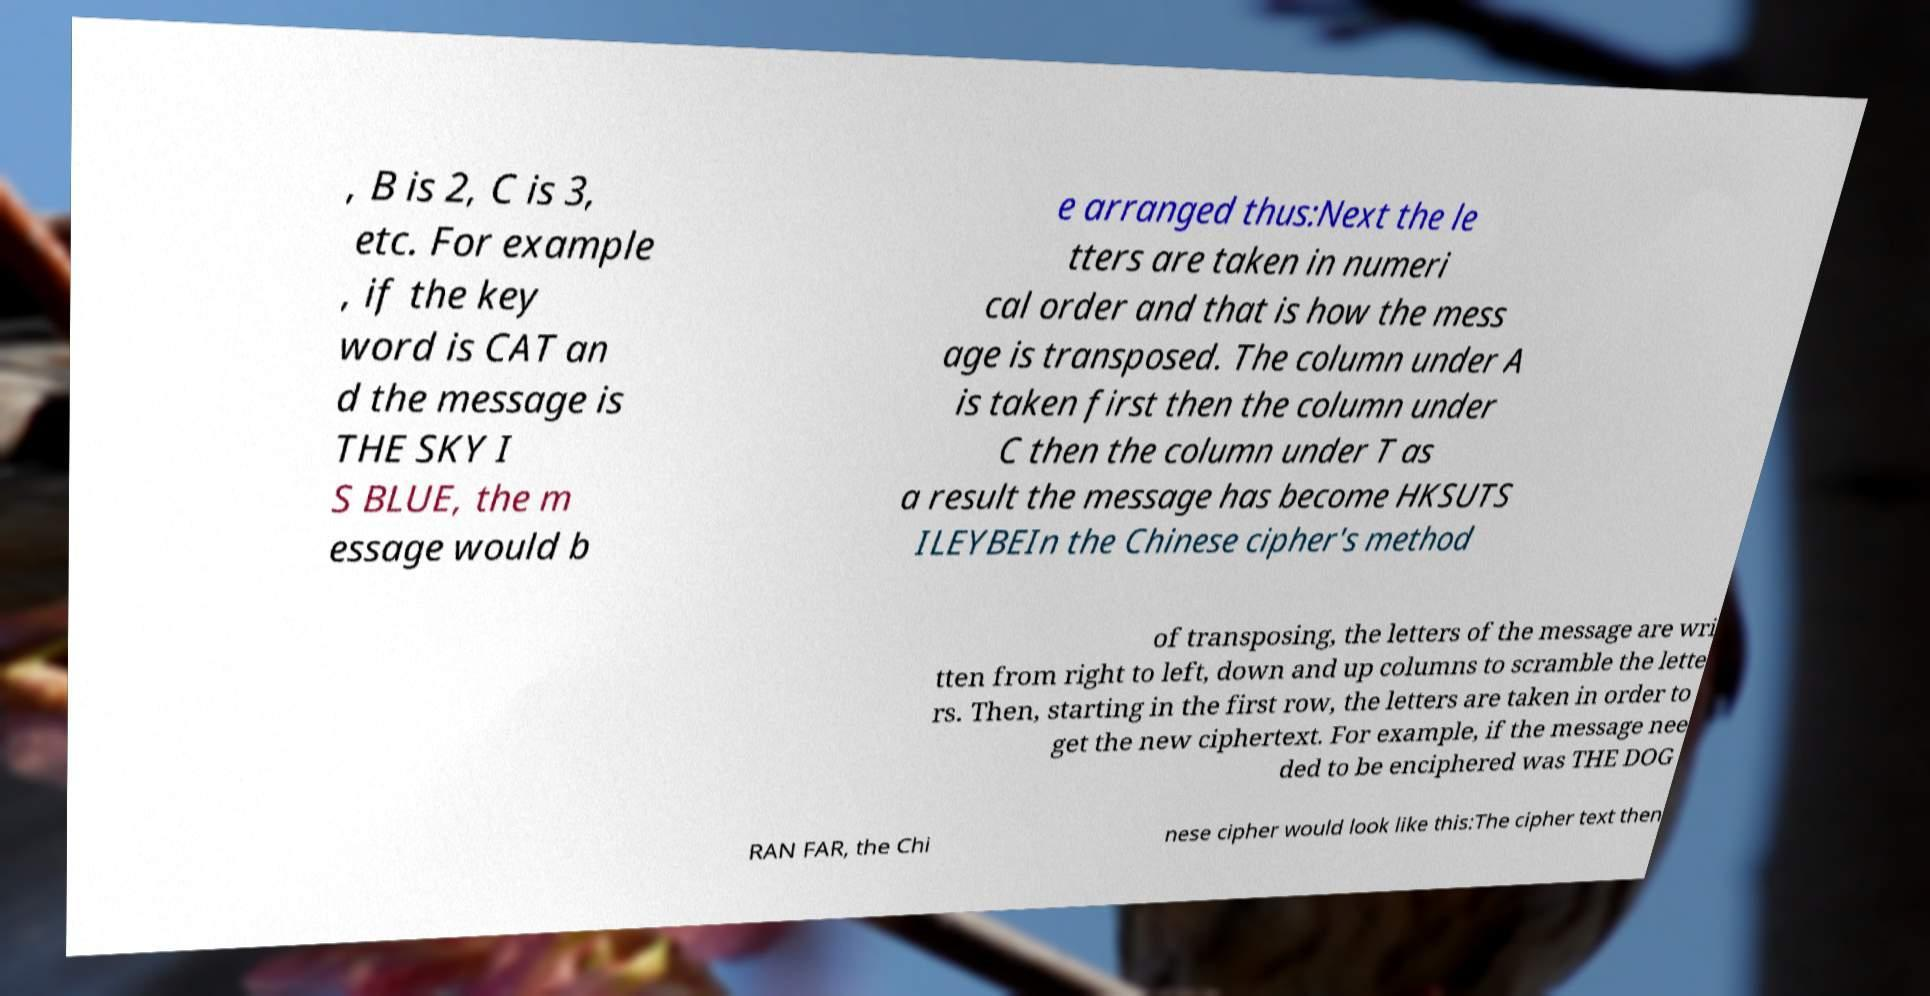I need the written content from this picture converted into text. Can you do that? , B is 2, C is 3, etc. For example , if the key word is CAT an d the message is THE SKY I S BLUE, the m essage would b e arranged thus:Next the le tters are taken in numeri cal order and that is how the mess age is transposed. The column under A is taken first then the column under C then the column under T as a result the message has become HKSUTS ILEYBEIn the Chinese cipher's method of transposing, the letters of the message are wri tten from right to left, down and up columns to scramble the lette rs. Then, starting in the first row, the letters are taken in order to get the new ciphertext. For example, if the message nee ded to be enciphered was THE DOG RAN FAR, the Chi nese cipher would look like this:The cipher text then 